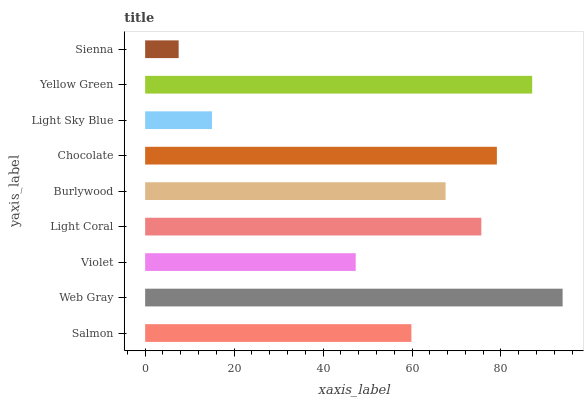Is Sienna the minimum?
Answer yes or no. Yes. Is Web Gray the maximum?
Answer yes or no. Yes. Is Violet the minimum?
Answer yes or no. No. Is Violet the maximum?
Answer yes or no. No. Is Web Gray greater than Violet?
Answer yes or no. Yes. Is Violet less than Web Gray?
Answer yes or no. Yes. Is Violet greater than Web Gray?
Answer yes or no. No. Is Web Gray less than Violet?
Answer yes or no. No. Is Burlywood the high median?
Answer yes or no. Yes. Is Burlywood the low median?
Answer yes or no. Yes. Is Light Sky Blue the high median?
Answer yes or no. No. Is Violet the low median?
Answer yes or no. No. 